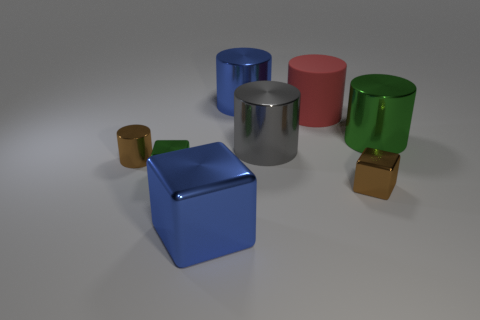Is there any other thing that is made of the same material as the large red object?
Your answer should be compact. No. There is a cylinder on the left side of the large blue thing that is in front of the blue cylinder behind the large green metallic cylinder; what is its color?
Keep it short and to the point. Brown. What number of blue metal objects have the same size as the brown metal cylinder?
Ensure brevity in your answer.  0. Are there more tiny shiny cylinders to the left of the big green object than big green metallic cylinders that are in front of the large gray metal cylinder?
Your response must be concise. Yes. There is a large metallic block to the left of the small metallic cube that is right of the big blue block; what is its color?
Provide a succinct answer. Blue. Is the gray cylinder made of the same material as the blue block?
Give a very brief answer. Yes. Is there a large blue thing of the same shape as the gray metallic thing?
Your answer should be very brief. Yes. There is a small cube that is on the right side of the big gray cylinder; is its color the same as the small cylinder?
Make the answer very short. Yes. Is the size of the blue object in front of the small brown block the same as the green object to the left of the big block?
Offer a terse response. No. The brown cylinder that is the same material as the gray cylinder is what size?
Offer a terse response. Small. 